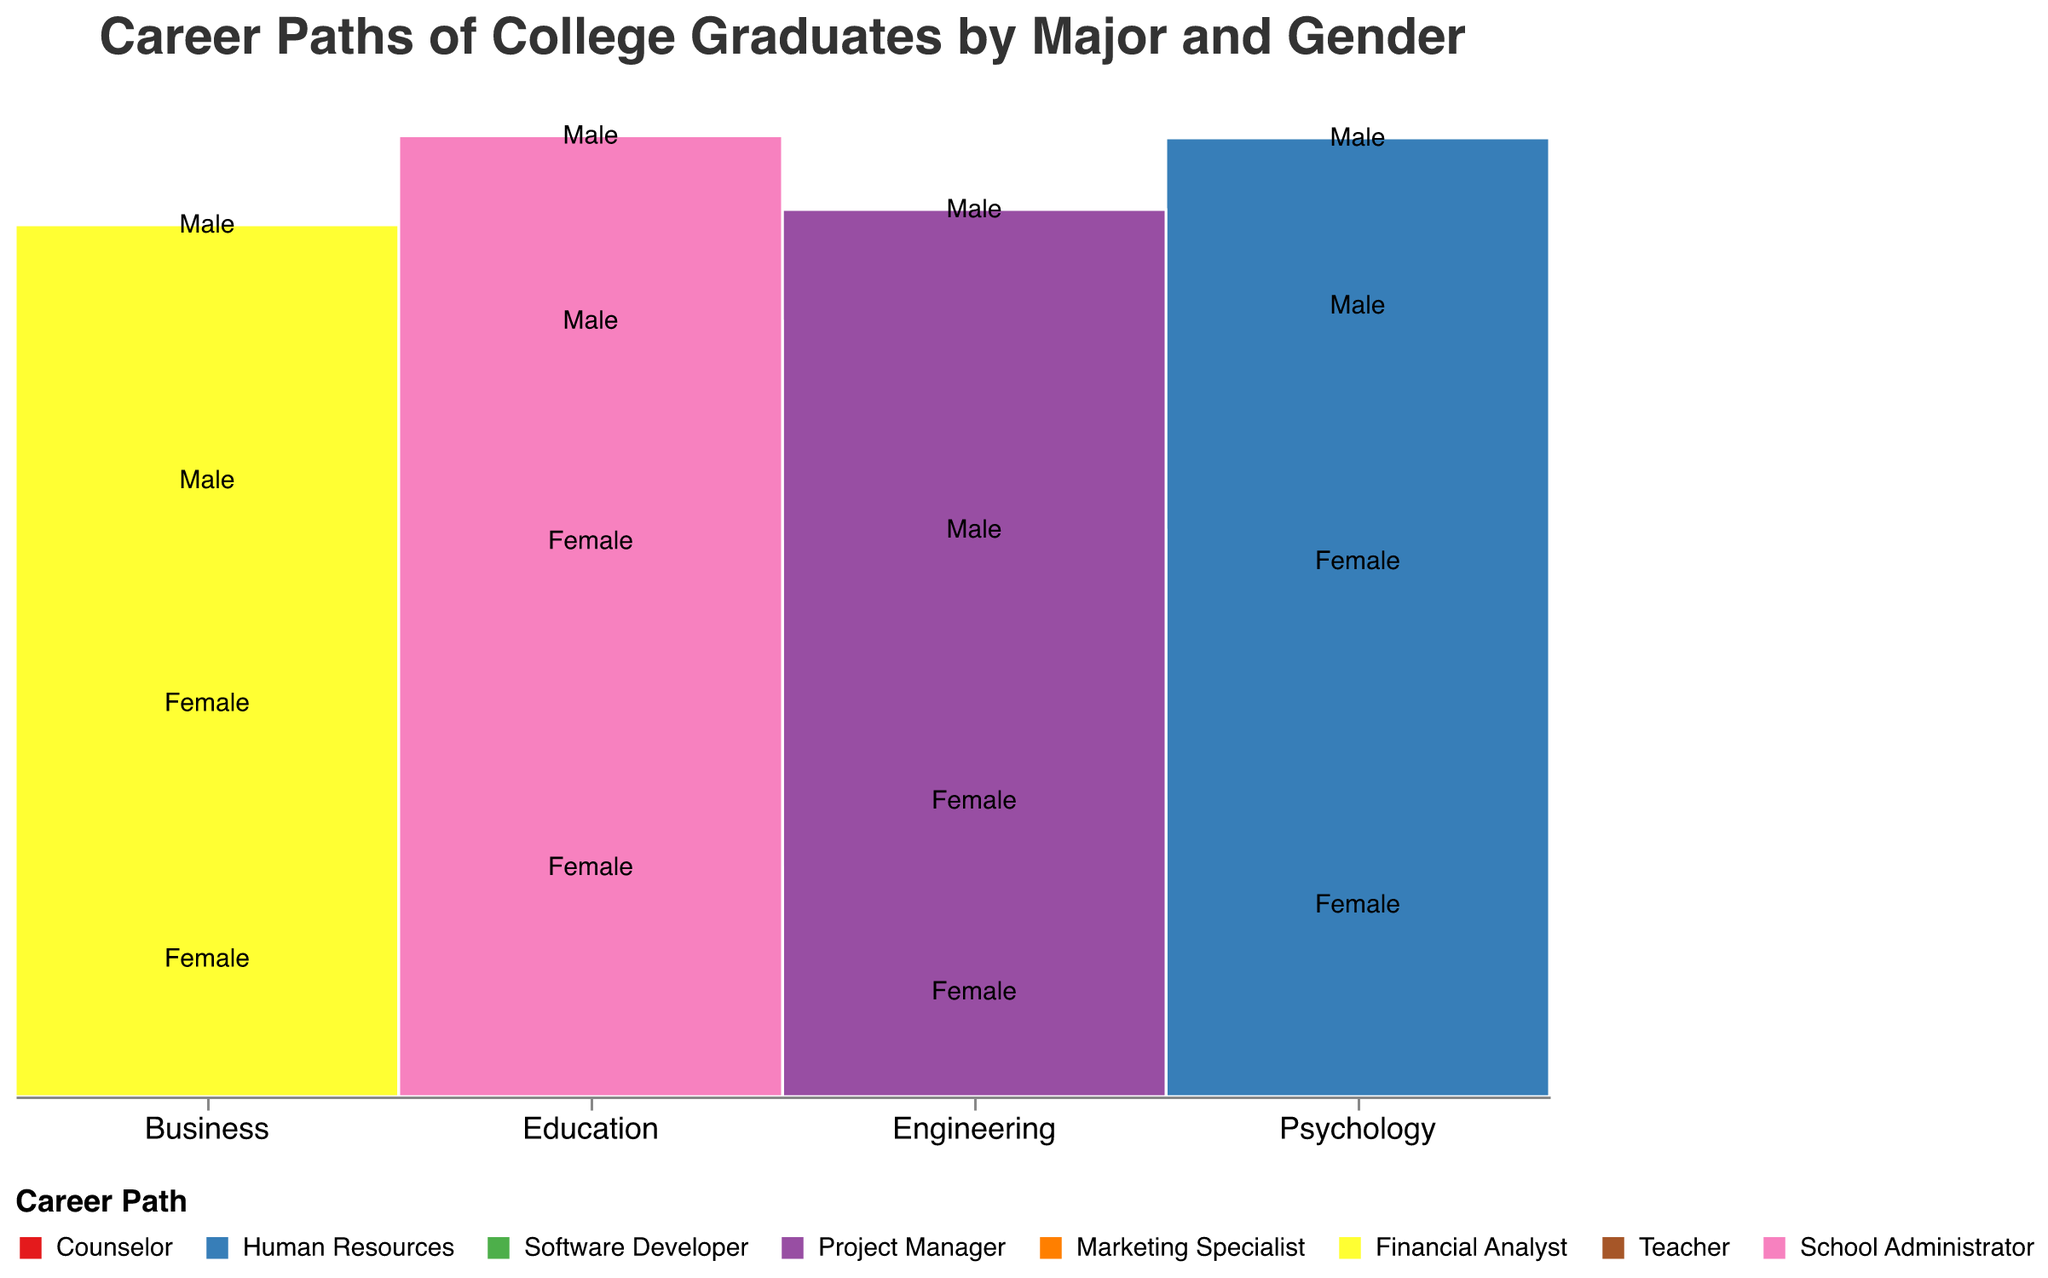What is the most common career path for female Psychology majors? The plot shows that among female Psychology majors, the section for "Counselor" is the largest compared to "Human Resources."
Answer: Counselor Which gender has more individuals in the Software Developer career path within Engineering? By comparing the sizes of the sections for male and female in Engineering's Software Developer path, the section for males is larger.
Answer: Male How does the number of male Marketing Specialists in Business compare to female Financial Analysts in Business? We need to compare the height of the male section for Marketing Specialists with the female section for Financial Analysts within the Business major. Male Marketing Specialists have a smaller section than female Financial Analysts.
Answer: Fewer Within the Education major, which gender has more graduates becoming School Administrators? Looking at the Education sections for both genders, the male section for School Administrators is smaller than the female section.
Answer: Female What career path has the least number of individuals among male Engineering graduates? By examining the two sections for male Engineering graduates, Project Manager has fewer individuals than Software Developer.
Answer: Project Manager How do the numbers of female Teacher graduates in Education compare to male Financial Analysts in Business? By looking at the relative sizes of the sections for female Teachers in Education and male Financial Analysts in Business, the female Teacher section is taller.
Answer: More What's the most common career path for male graduates in Business? The Business sections for male graduates show that the section for Financial Analysts is larger than that for Marketing Specialists.
Answer: Financial Analyst Are there more female Project Managers in Engineering or female Marketing Specialists in Business? By comparing the size of the female Project Managers section in Engineering to the female Marketing Specialists section in Business, the Business section is larger.
Answer: Female Marketing Specialists in Business Which major has the highest number of female graduates becoming Teachers? Looking at the sections for female Teachers across all majors, the Education major has the largest section.
Answer: Education How does the total number of male graduates in Engineering compare to those in Psychology? Sum the counts for all career paths for males in Engineering (Software Developer and Project Manager) and compare it to the sum for males in Psychology (Counselor and Human Resources). Engineering has a higher sum.
Answer: Higher 